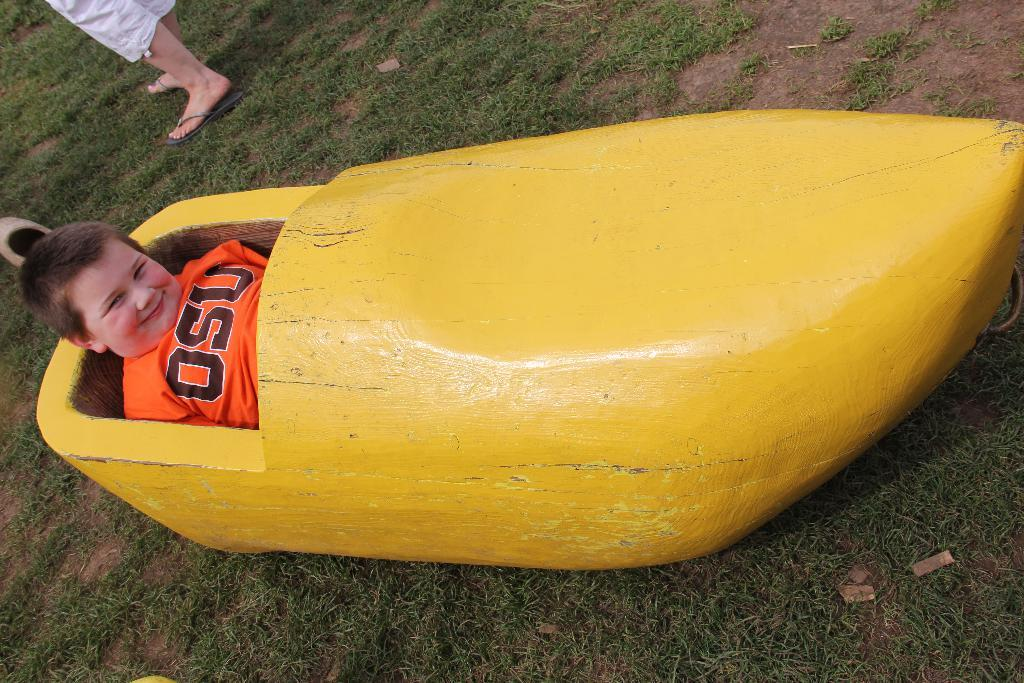Provide a one-sentence caption for the provided image. a child wearing an orange OSU shirt inside a yellow canoe. 